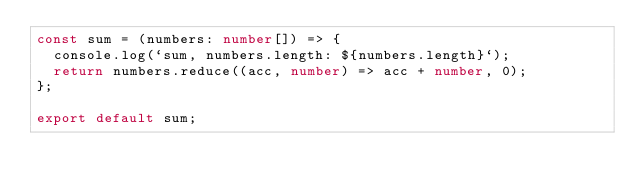Convert code to text. <code><loc_0><loc_0><loc_500><loc_500><_TypeScript_>const sum = (numbers: number[]) => {
  console.log(`sum, numbers.length: ${numbers.length}`);
  return numbers.reduce((acc, number) => acc + number, 0);
};

export default sum;
</code> 